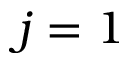<formula> <loc_0><loc_0><loc_500><loc_500>j = 1</formula> 